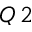<formula> <loc_0><loc_0><loc_500><loc_500>Q \, 2</formula> 